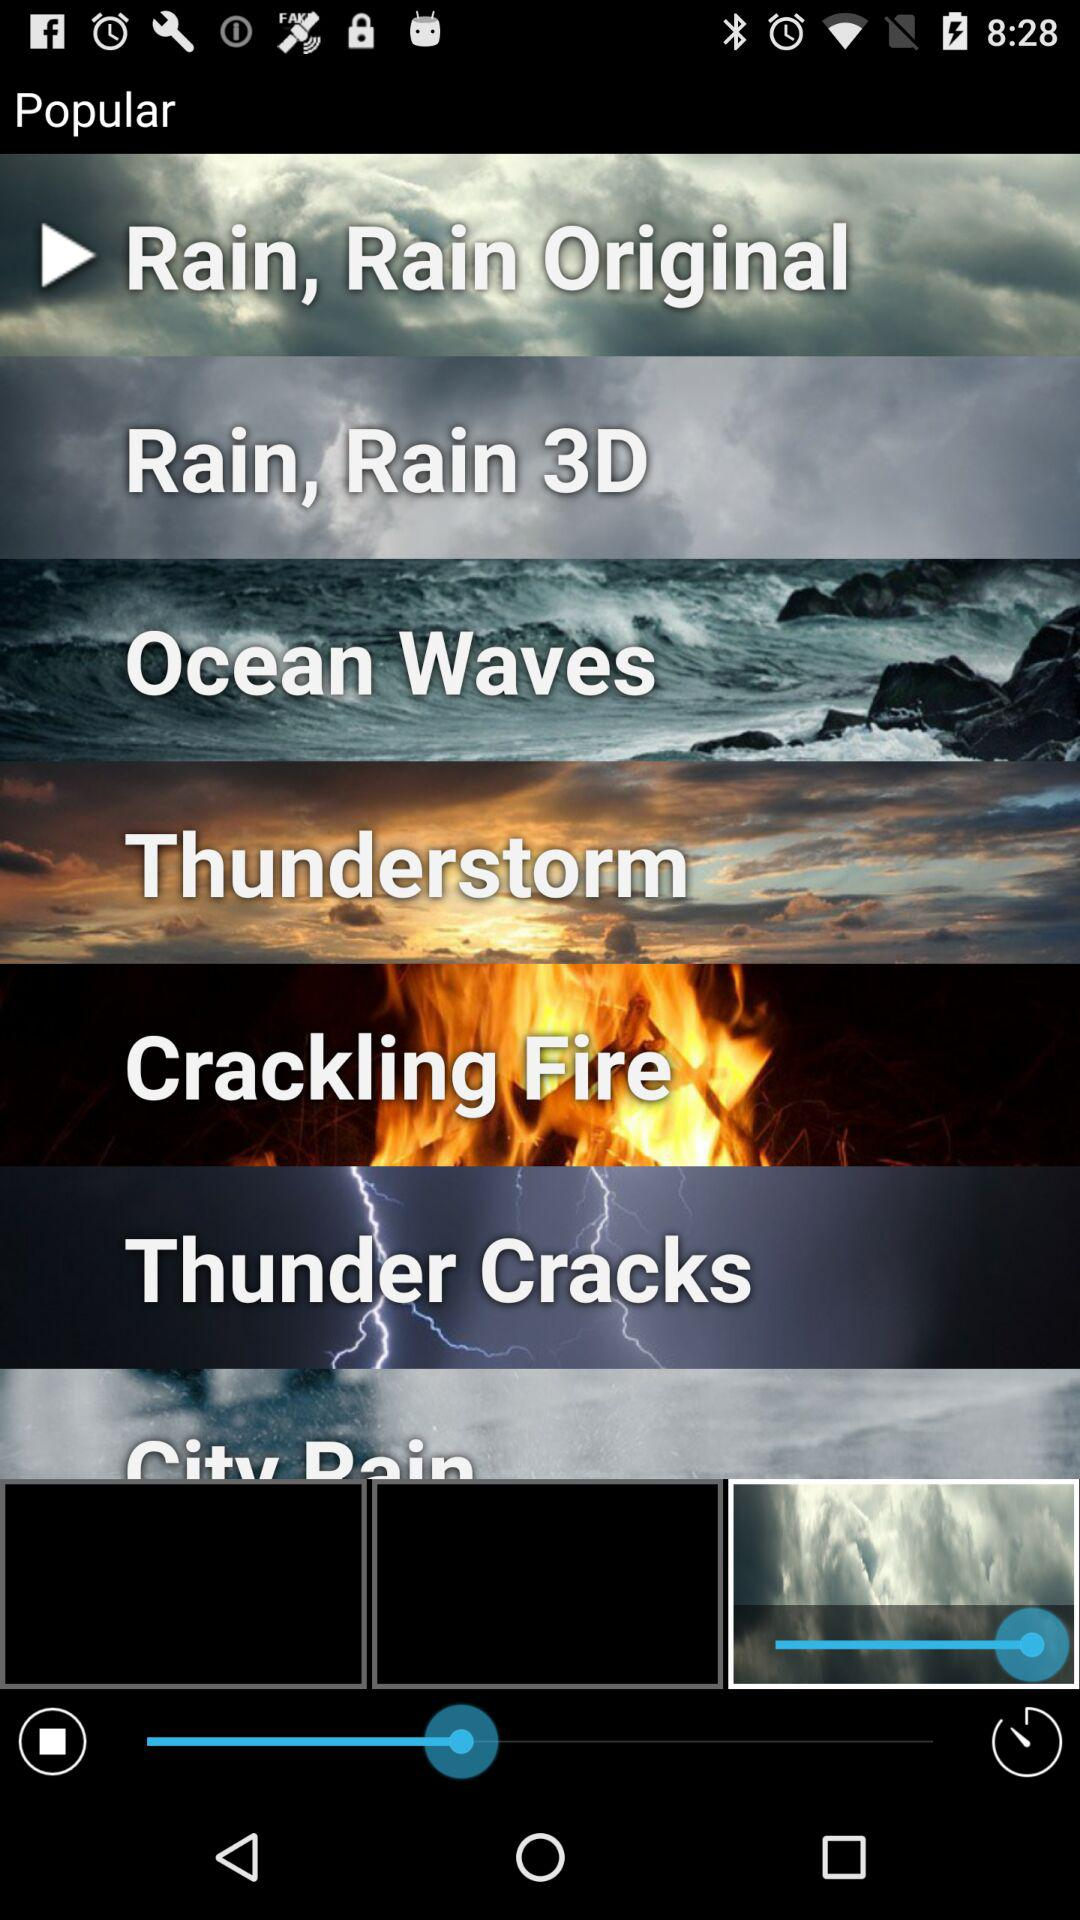Which popular audio is selected? The selected audio is "Rain, Rain Original". 